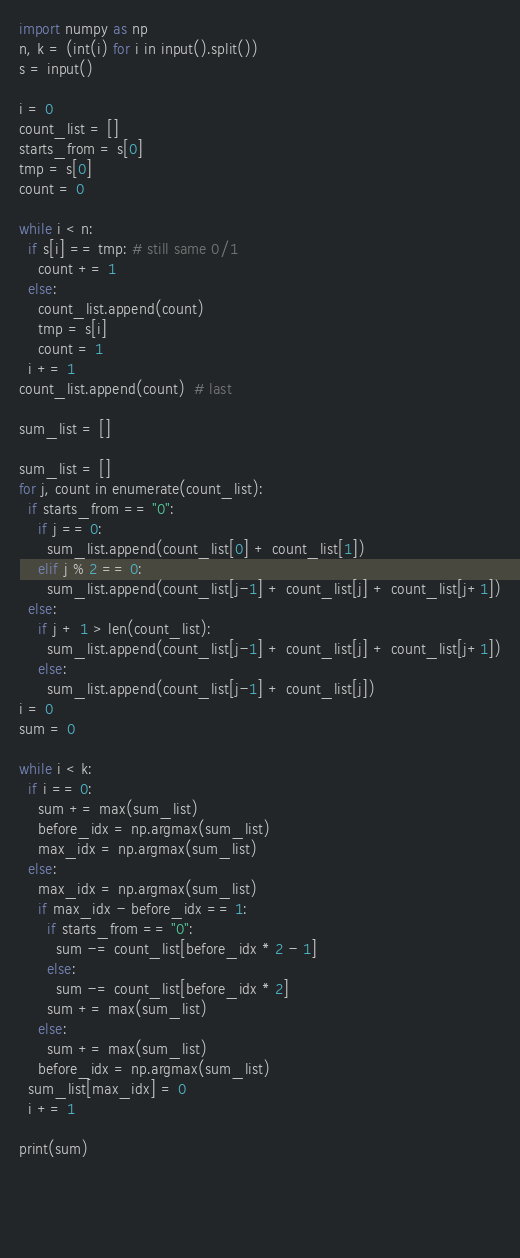<code> <loc_0><loc_0><loc_500><loc_500><_Python_>import numpy as np
n, k = (int(i) for i in input().split())  
s = input()

i = 0
count_list = []
starts_from = s[0]
tmp = s[0]
count = 0

while i < n:
  if s[i] == tmp: # still same 0/1
    count += 1
  else:
    count_list.append(count)
    tmp = s[i]
    count = 1
  i += 1
count_list.append(count)  # last

sum_list = []

sum_list = []
for j, count in enumerate(count_list):
  if starts_from == "0":
    if j == 0:
      sum_list.append(count_list[0] + count_list[1])
    elif j % 2 == 0:
      sum_list.append(count_list[j-1] + count_list[j] + count_list[j+1])
  else:
    if j + 1 > len(count_list):
      sum_list.append(count_list[j-1] + count_list[j] + count_list[j+1])
    else:
      sum_list.append(count_list[j-1] + count_list[j])
i = 0
sum = 0

while i < k:
  if i == 0:
    sum += max(sum_list)
    before_idx = np.argmax(sum_list)
    max_idx = np.argmax(sum_list) 
  else:
    max_idx = np.argmax(sum_list)
    if max_idx - before_idx == 1:
      if starts_from == "0":
        sum -= count_list[before_idx * 2 - 1]
      else:
        sum -= count_list[before_idx * 2]
      sum += max(sum_list)
    else:
      sum += max(sum_list)
    before_idx = np.argmax(sum_list) 
  sum_list[max_idx] = 0
  i += 1

print(sum)
    

  
  
</code> 